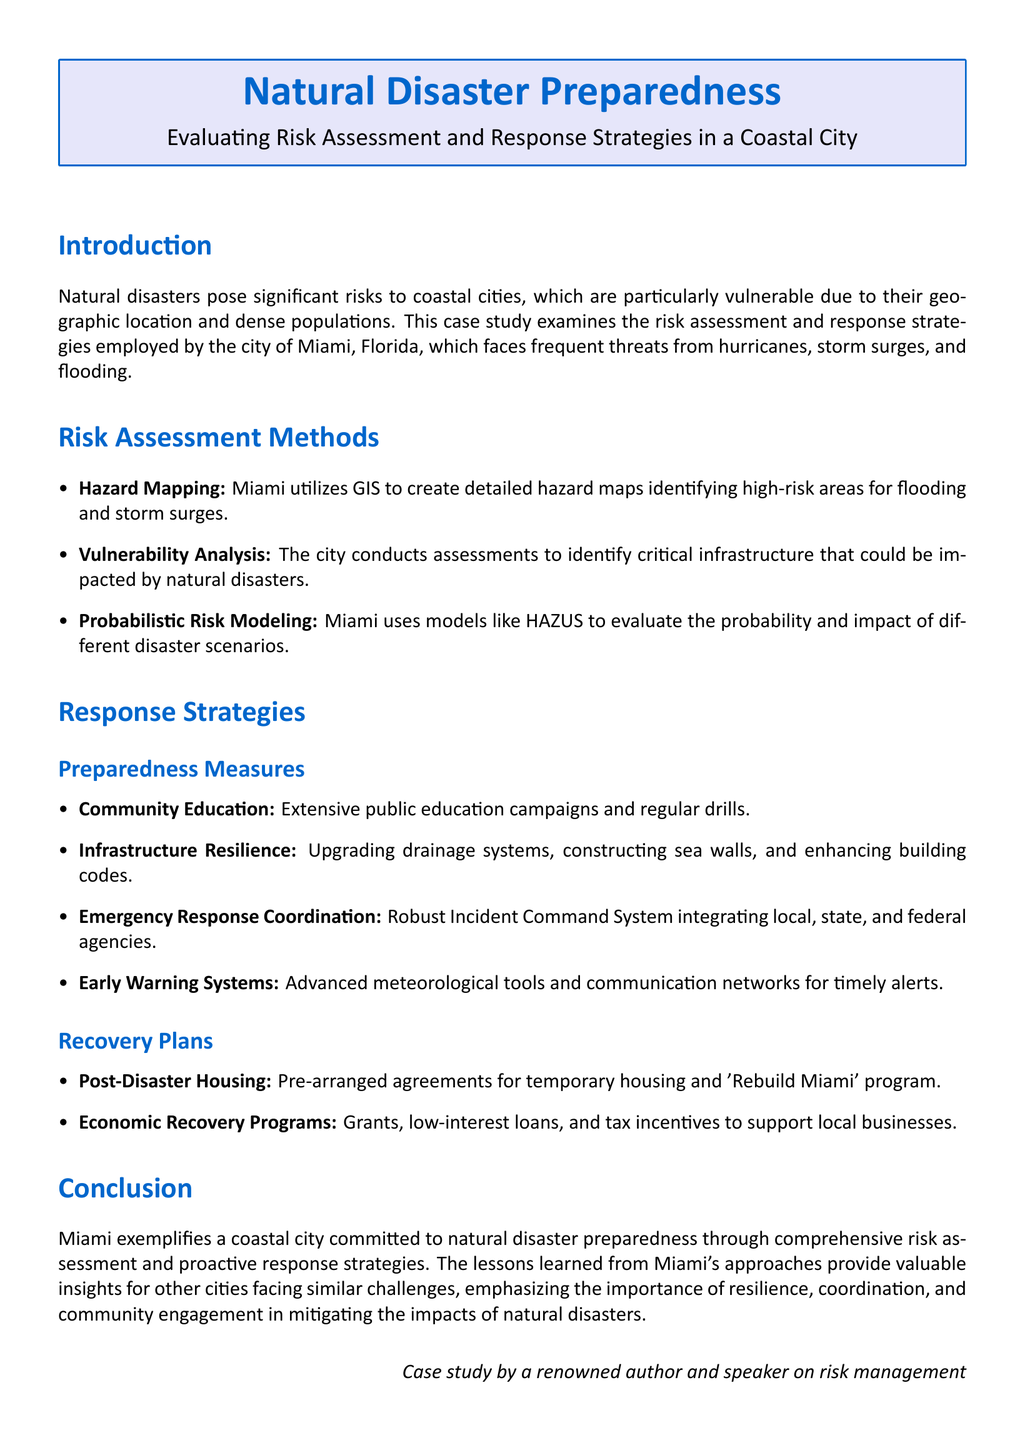What is the primary focus of the case study? The case study focuses on evaluating risk assessment and response strategies in the context of natural disaster preparedness.
Answer: Natural disaster preparedness Which coastal city is the case study centered on? The case study examines the strategies employed by the coastal city of Miami, Florida.
Answer: Miami What mapping technology does Miami use for hazard assessment? Miami utilizes GIS to create detailed hazard maps identifying high-risk areas.
Answer: GIS Name one preparedness measure mentioned in the response strategies. The case study lists community education as one of the preparedness measures.
Answer: Community education What program is in place for post-disaster housing in Miami? The case study mentions a 'Rebuild Miami' program for post-disaster housing arrangements.
Answer: Rebuild Miami What type of analysis is conducted to identify critical infrastructure vulnerabilities? The city conducts vulnerability analysis to identify critical infrastructure impacted by disasters.
Answer: Vulnerability analysis What is a key element of Miami's emergency response coordination? The document highlights a robust Incident Command System as a key element of coordination.
Answer: Incident Command System Which tool is used to evaluate disaster scenarios probabilistically? Miami uses models like HAZUS for probabilistic risk modeling of disaster scenarios.
Answer: HAZUS How does the document categorize response strategies? The case study categorizes response strategies into preparedness measures and recovery plans.
Answer: Preparedness measures and recovery plans 